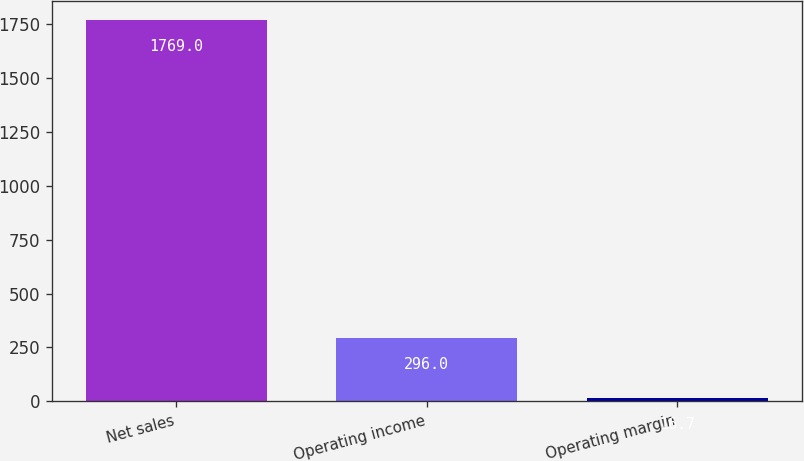<chart> <loc_0><loc_0><loc_500><loc_500><bar_chart><fcel>Net sales<fcel>Operating income<fcel>Operating margin<nl><fcel>1769<fcel>296<fcel>16.7<nl></chart> 